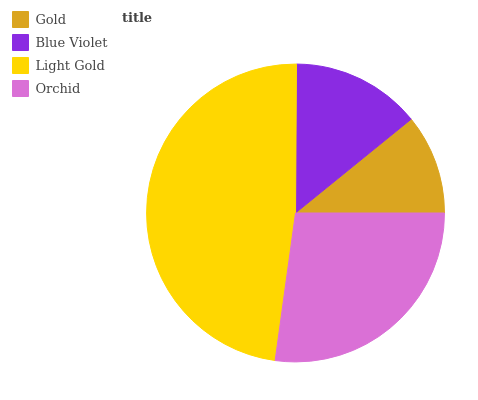Is Gold the minimum?
Answer yes or no. Yes. Is Light Gold the maximum?
Answer yes or no. Yes. Is Blue Violet the minimum?
Answer yes or no. No. Is Blue Violet the maximum?
Answer yes or no. No. Is Blue Violet greater than Gold?
Answer yes or no. Yes. Is Gold less than Blue Violet?
Answer yes or no. Yes. Is Gold greater than Blue Violet?
Answer yes or no. No. Is Blue Violet less than Gold?
Answer yes or no. No. Is Orchid the high median?
Answer yes or no. Yes. Is Blue Violet the low median?
Answer yes or no. Yes. Is Blue Violet the high median?
Answer yes or no. No. Is Orchid the low median?
Answer yes or no. No. 